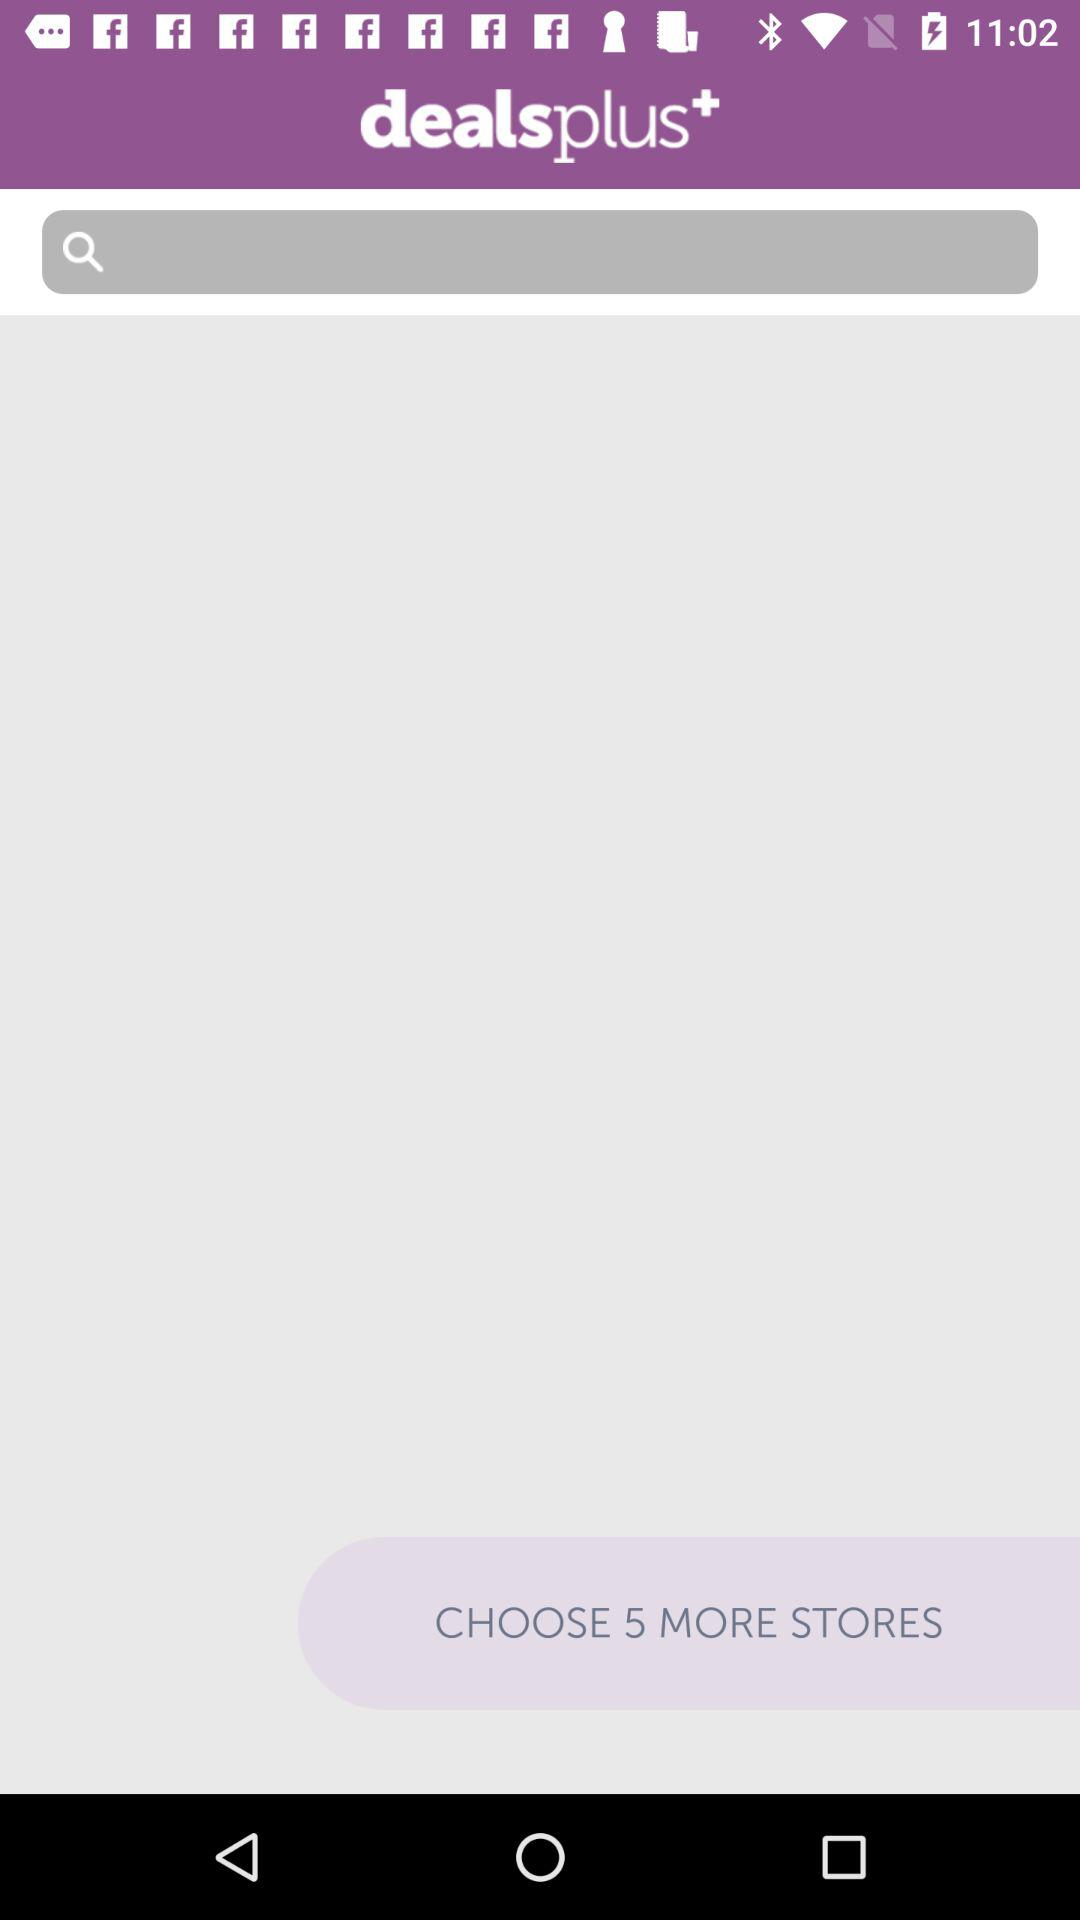How many more stores can be chosen?
Answer the question using a single word or phrase. 5 